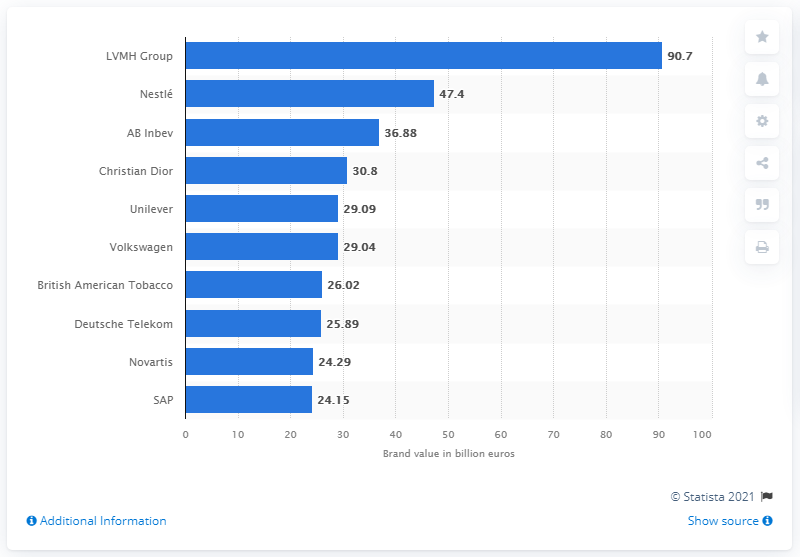List a handful of essential elements in this visual. The most valuable corporate brand in Europe in 2020 had a value of 90.7. 